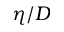Convert formula to latex. <formula><loc_0><loc_0><loc_500><loc_500>\eta / D</formula> 